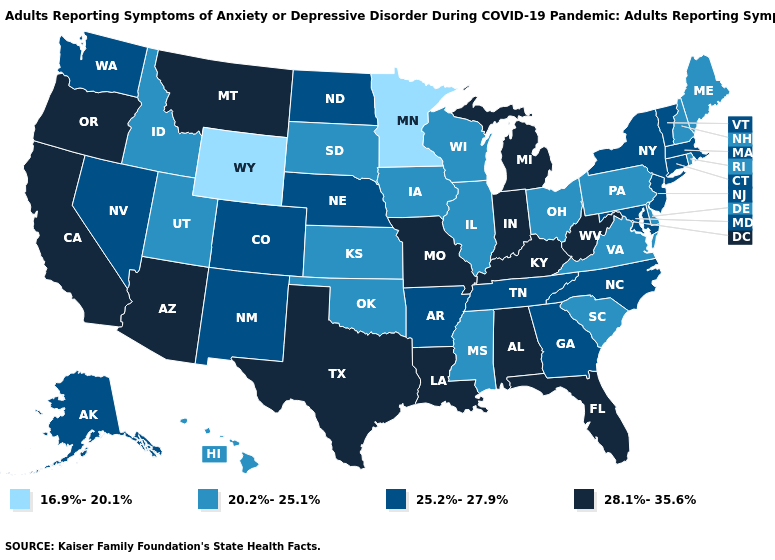Which states hav the highest value in the Northeast?
Short answer required. Connecticut, Massachusetts, New Jersey, New York, Vermont. What is the highest value in the USA?
Quick response, please. 28.1%-35.6%. Does the map have missing data?
Concise answer only. No. What is the value of Wisconsin?
Give a very brief answer. 20.2%-25.1%. What is the value of New Jersey?
Keep it brief. 25.2%-27.9%. Which states have the lowest value in the USA?
Concise answer only. Minnesota, Wyoming. Which states have the highest value in the USA?
Quick response, please. Alabama, Arizona, California, Florida, Indiana, Kentucky, Louisiana, Michigan, Missouri, Montana, Oregon, Texas, West Virginia. Does Michigan have a lower value than South Dakota?
Answer briefly. No. What is the value of New Hampshire?
Quick response, please. 20.2%-25.1%. What is the lowest value in the USA?
Quick response, please. 16.9%-20.1%. Does the first symbol in the legend represent the smallest category?
Answer briefly. Yes. Name the states that have a value in the range 28.1%-35.6%?
Concise answer only. Alabama, Arizona, California, Florida, Indiana, Kentucky, Louisiana, Michigan, Missouri, Montana, Oregon, Texas, West Virginia. What is the value of New Hampshire?
Give a very brief answer. 20.2%-25.1%. Among the states that border Arkansas , does Missouri have the lowest value?
Short answer required. No. Name the states that have a value in the range 20.2%-25.1%?
Quick response, please. Delaware, Hawaii, Idaho, Illinois, Iowa, Kansas, Maine, Mississippi, New Hampshire, Ohio, Oklahoma, Pennsylvania, Rhode Island, South Carolina, South Dakota, Utah, Virginia, Wisconsin. 